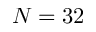<formula> <loc_0><loc_0><loc_500><loc_500>N = 3 2</formula> 